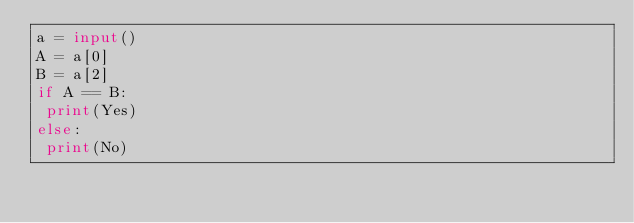<code> <loc_0><loc_0><loc_500><loc_500><_Python_>a = input()
A = a[0]
B = a[2]
if A == B:
 print(Yes)
else:
 print(No)</code> 